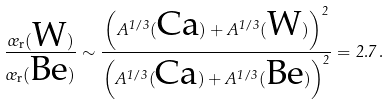Convert formula to latex. <formula><loc_0><loc_0><loc_500><loc_500>\frac { \sigma _ { \text {r} } ( \text {W} ) } { \sigma _ { \text {r} } ( \text {Be} ) } \sim \frac { \left ( A ^ { 1 / 3 } ( \text {Ca} ) + A ^ { 1 / 3 } ( \text {W} ) \right ) ^ { 2 } } { \left ( A ^ { 1 / 3 } ( \text {Ca} ) + A ^ { 1 / 3 } ( \text {Be} ) \right ) ^ { 2 } } = 2 . 7 \, .</formula> 